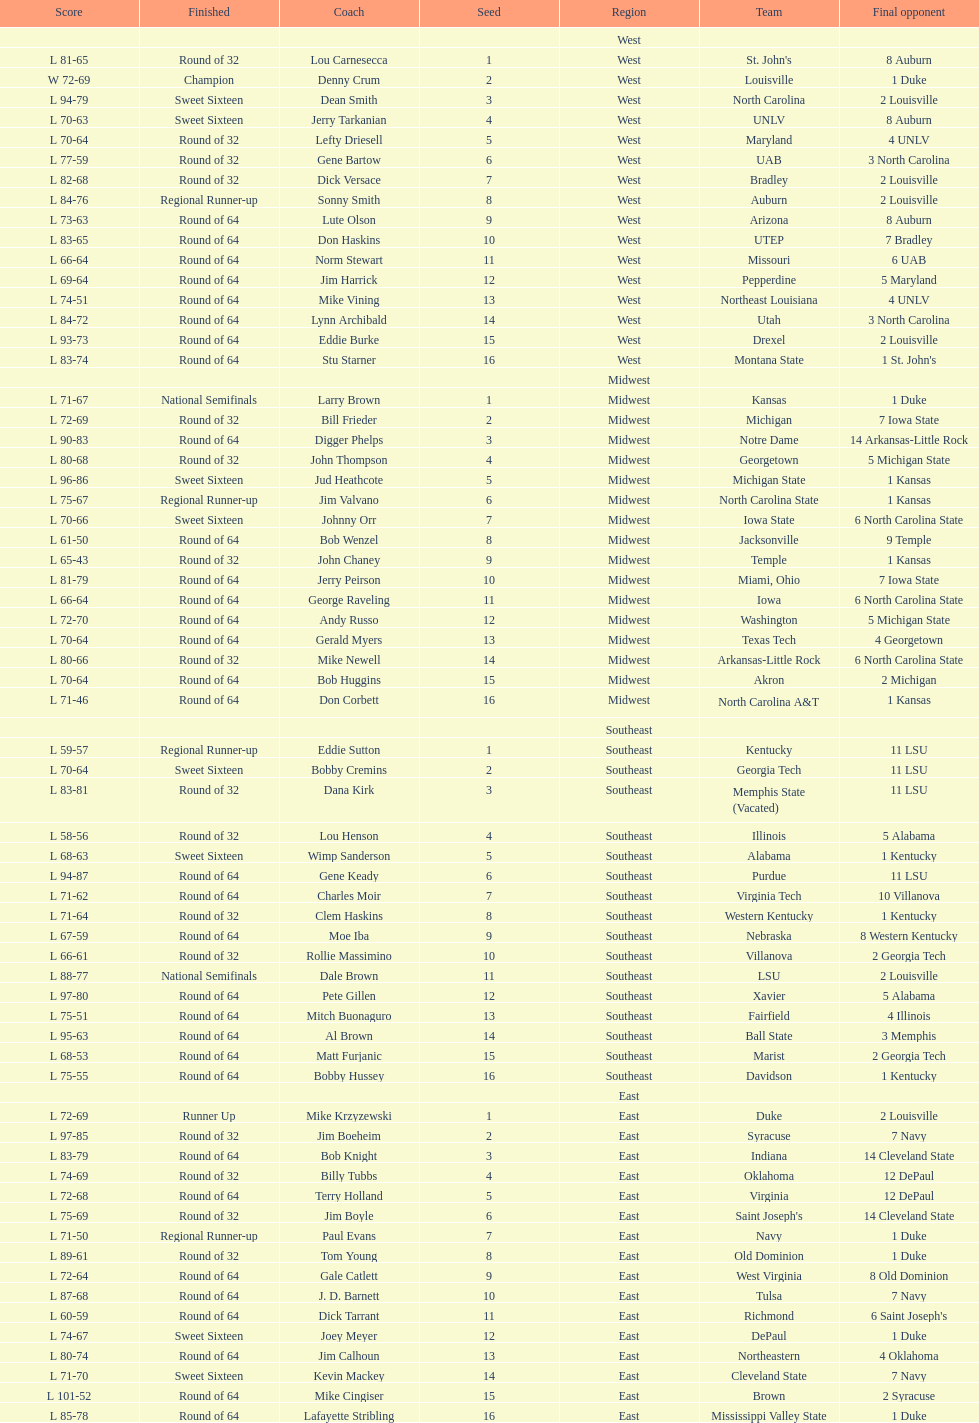Which team went finished later in the tournament, st. john's or north carolina a&t? North Carolina A&T. 